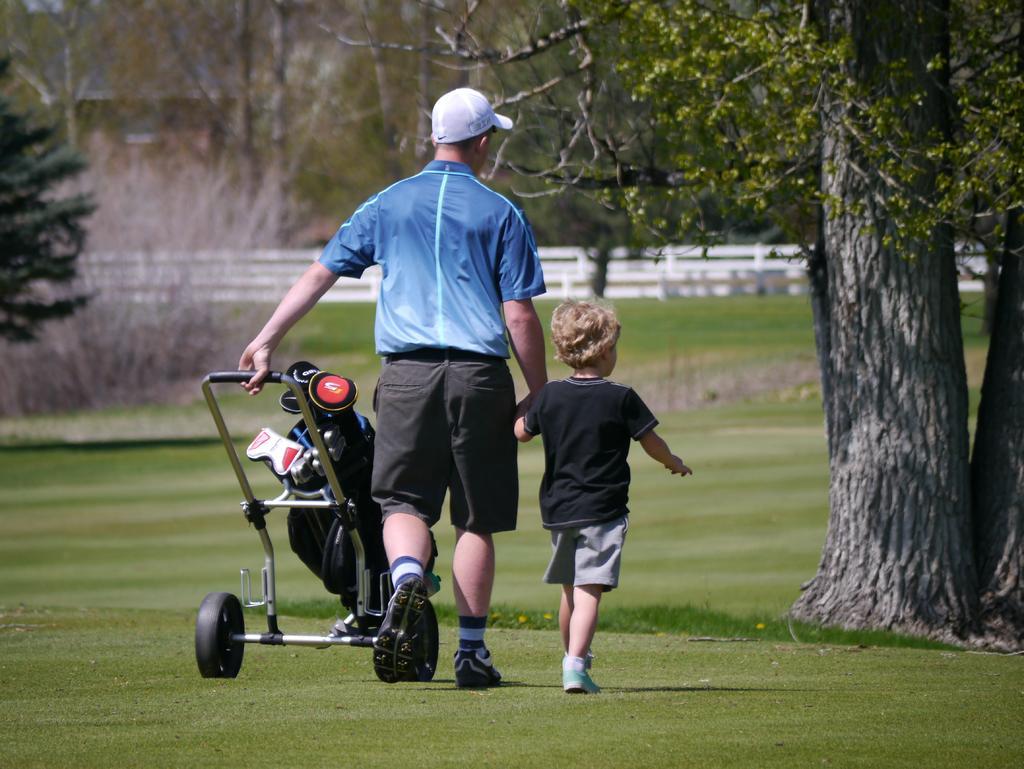How would you summarize this image in a sentence or two? In this picture we can see a man wearing blue t-shirt and shorts walking in the garden with a small boy. Beside there is a baby pram. Behind there is a white color fencing railing and some trees. On the front right corner there is a huge tree. 